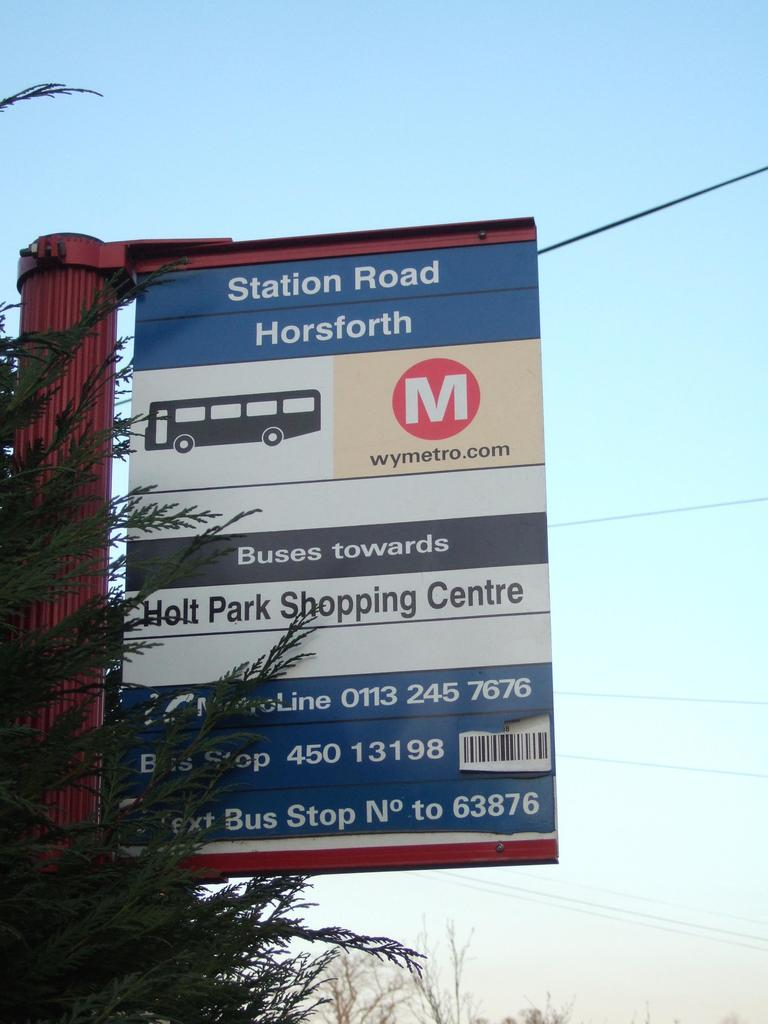Provide a one-sentence caption for the provided image. A transportation sign has information for buses going to Holt Park Shopping Centre. 